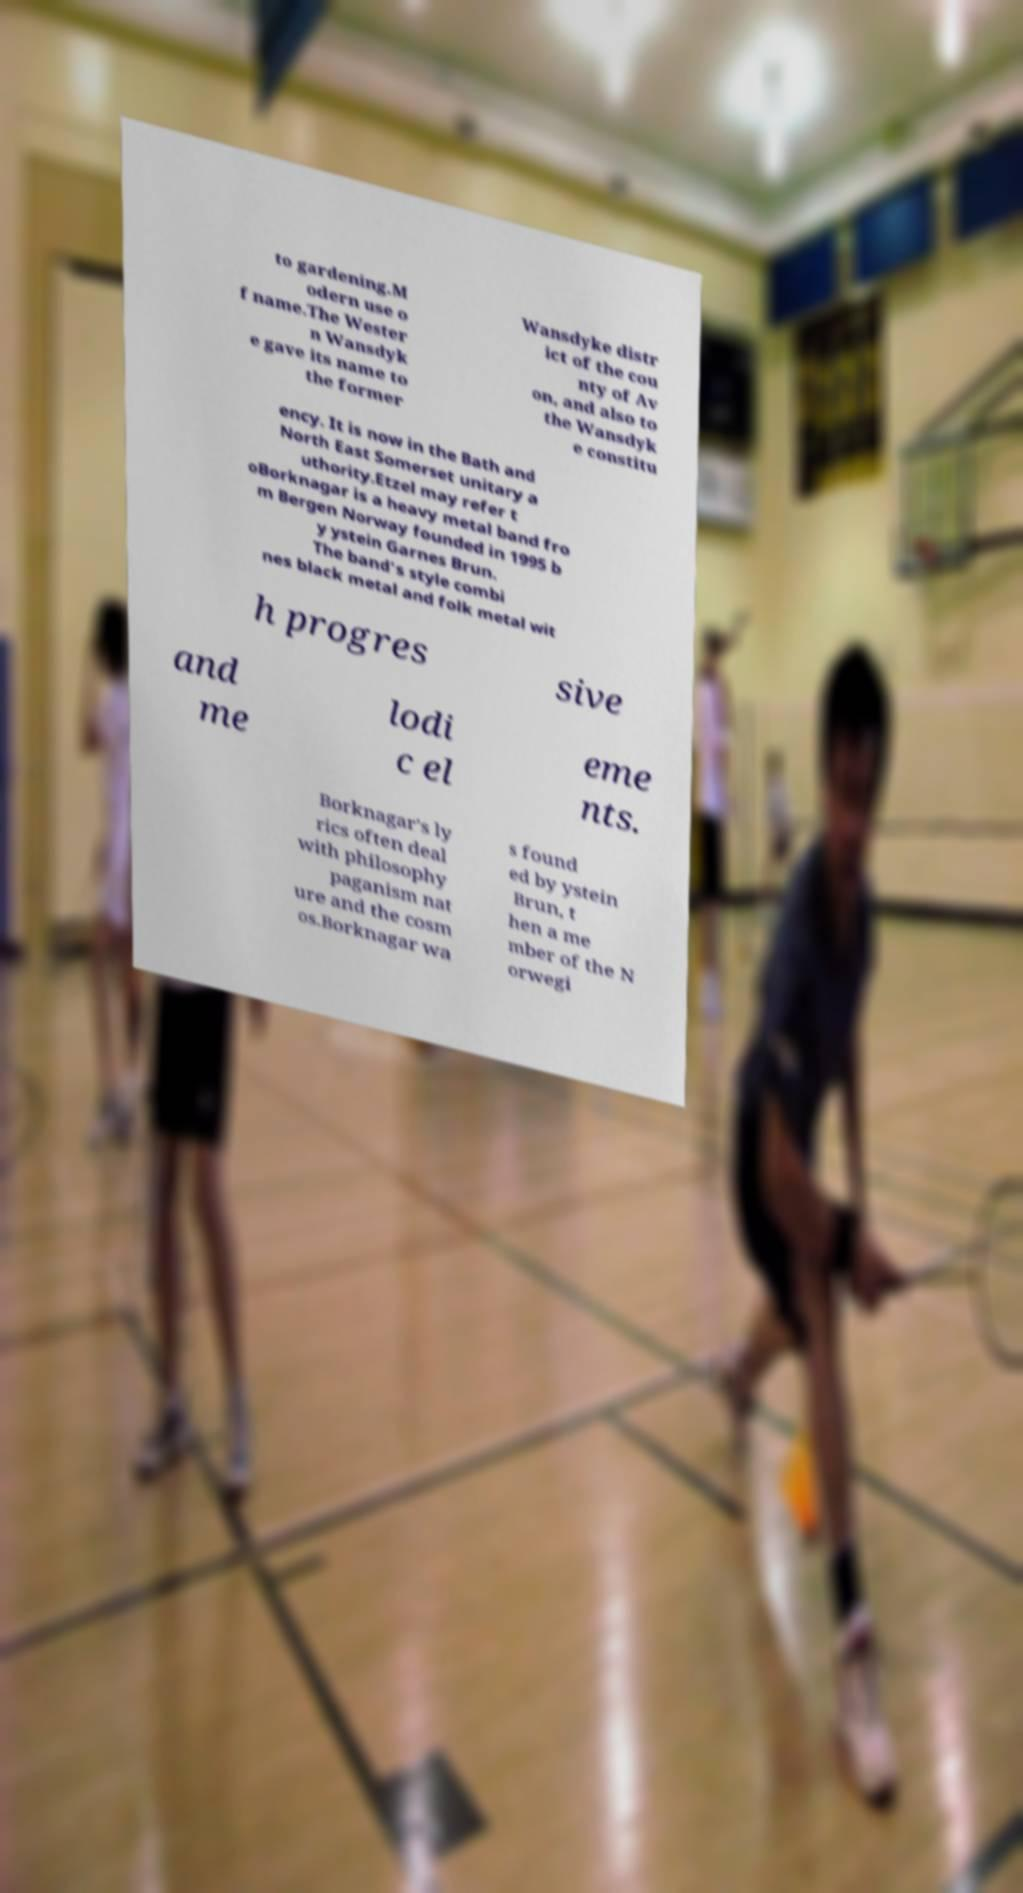Can you accurately transcribe the text from the provided image for me? to gardening.M odern use o f name.The Wester n Wansdyk e gave its name to the former Wansdyke distr ict of the cou nty of Av on, and also to the Wansdyk e constitu ency. It is now in the Bath and North East Somerset unitary a uthority.Etzel may refer t oBorknagar is a heavy metal band fro m Bergen Norway founded in 1995 b y ystein Garnes Brun. The band's style combi nes black metal and folk metal wit h progres sive and me lodi c el eme nts. Borknagar's ly rics often deal with philosophy paganism nat ure and the cosm os.Borknagar wa s found ed by ystein Brun, t hen a me mber of the N orwegi 